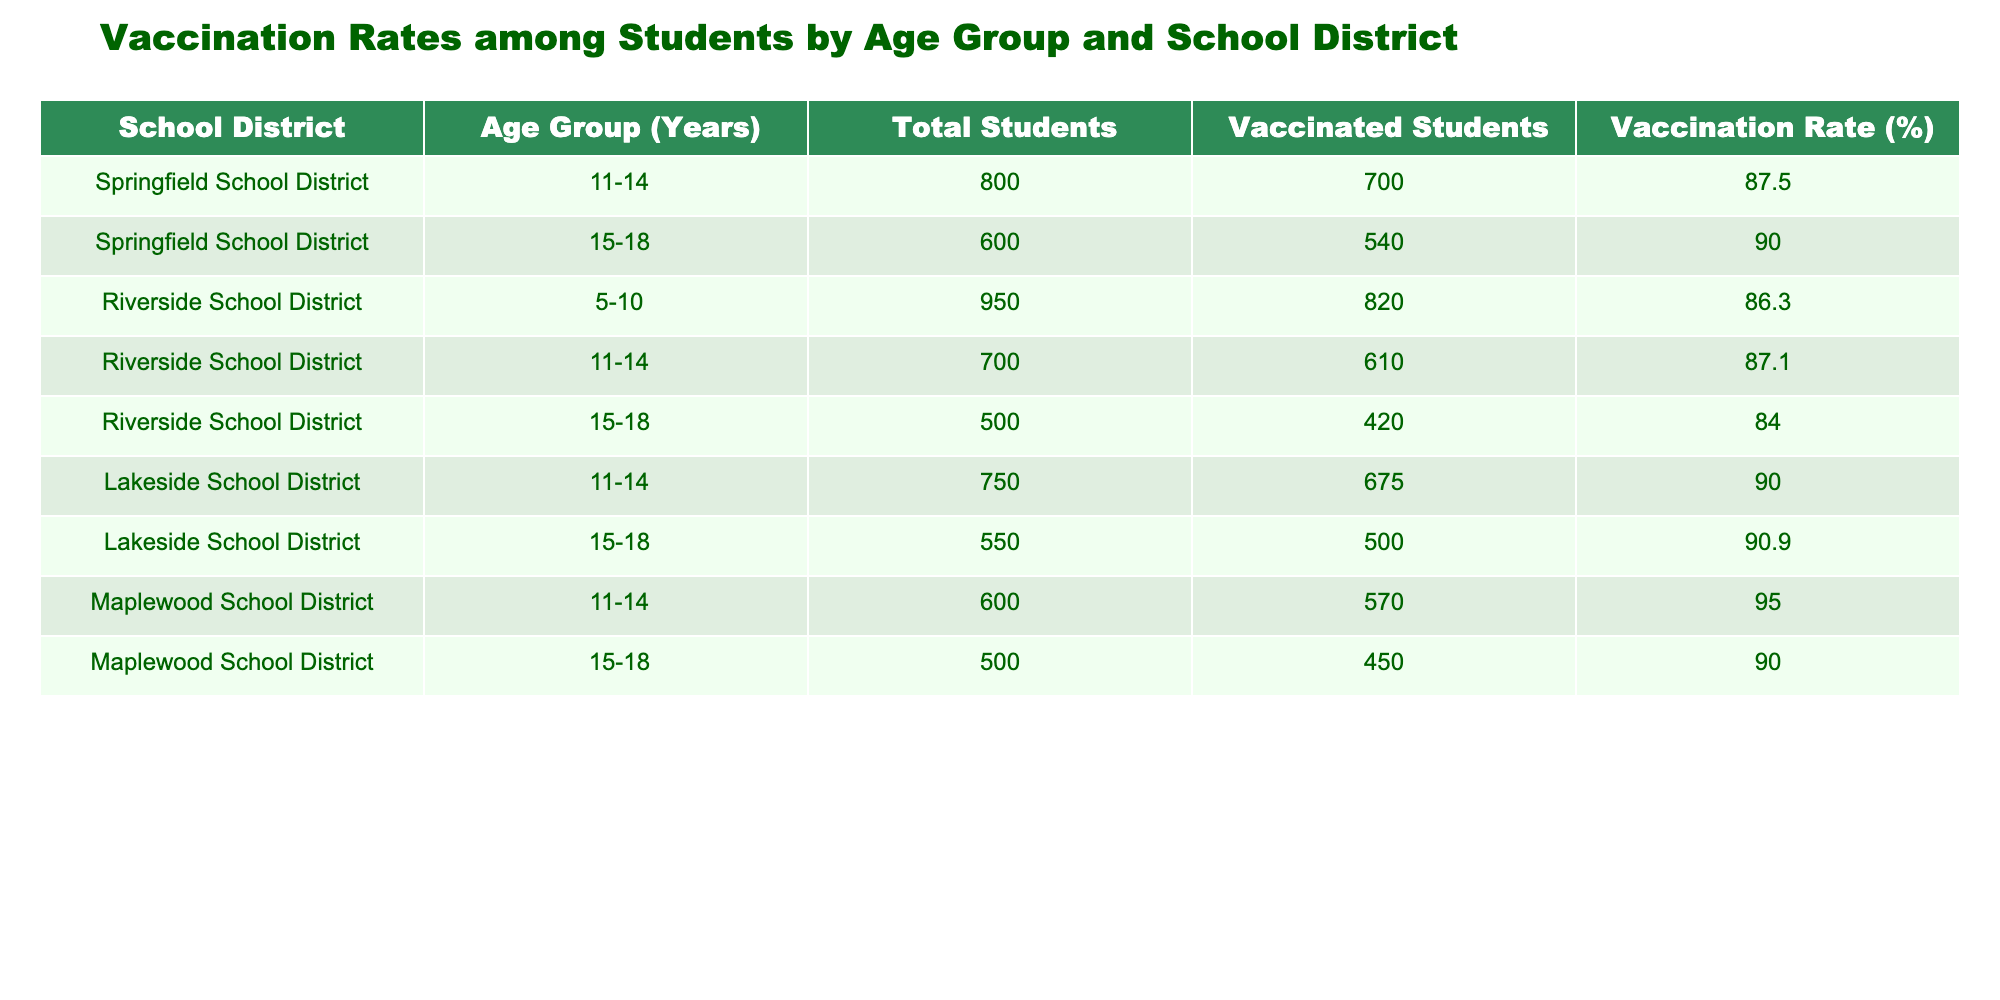What is the vaccination rate for students aged 11-14 in the Springfield School District? The vaccination rate for students aged 11-14 in the Springfield School District can be found directly in the table. According to the data, it is listed as 87.5%.
Answer: 87.5% Which school district has the highest vaccination rate among students aged 5-10? The table shows the vaccination rate for the 5-10 age group only for the Riverside School District, which is 86.3%. There are no other districts listed for this age group in the data.
Answer: Riverside School District What is the difference in vaccination rates between the 11-14 age group in Lakeside and Maplewood School Districts? The vaccination rate for the 11-14 age group in Lakeside School District is 90.0%, while that in Maplewood School District is 95.0%. The difference is calculated by subtracting Lakeside's rate from Maplewood's: 95.0% - 90.0% = 5.0%.
Answer: 5.0% Is it true that the vaccination rate for students aged 15-18 is lower in Riverside School District compared to Lakeside School District? According to the table, the vaccination rate for aged 15-18 in Riverside School District is 84.0%, while in Lakeside School District it is 90.9%. Since 84.0% is indeed lower than 90.9%, the statement is true.
Answer: Yes What is the average vaccination rate for all age groups across all school districts in the table? To find the average vaccination rate, sum the rates for each age group and divide by the number of entries. The rates are 87.5%, 90.0%, 86.3%, 87.1%, 84.0%, 90.0%, 90.9%, 95.0%, and 90.0%. Therefore, the sum is 87.5 + 90.0 + 86.3 + 87.1 + 84.0 + 90.0 + 90.9 + 95.0 + 90.0 = 819.8%, and by dividing by 9, the average is 819.8% / 9 = 91.09%.
Answer: 91.09% What percentage of students aged 15-18 in the Riverside School District are vaccinated? The vaccination status for students aged 15-18 in Riverside School District shows that there are 420 vaccinated students out of a total of 500. The vaccination rate is given directly in the table as 84.0%.
Answer: 84.0% 